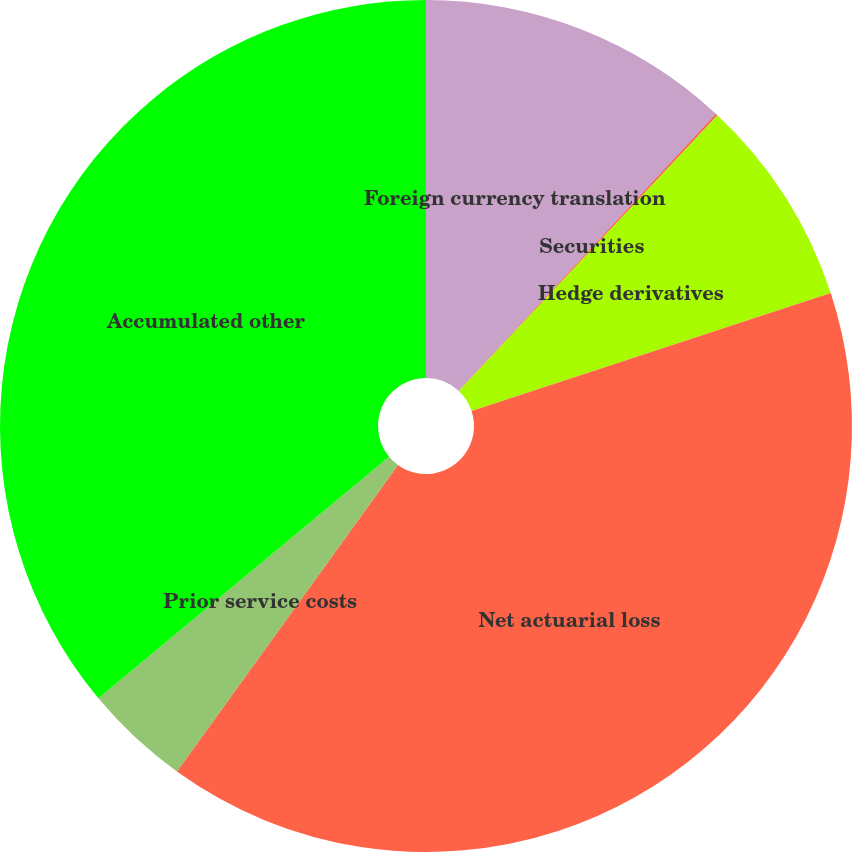<chart> <loc_0><loc_0><loc_500><loc_500><pie_chart><fcel>Foreign currency translation<fcel>Securities<fcel>Hedge derivatives<fcel>Net actuarial loss<fcel>Prior service costs<fcel>Accumulated other<nl><fcel>11.91%<fcel>0.08%<fcel>7.96%<fcel>39.99%<fcel>4.02%<fcel>36.04%<nl></chart> 